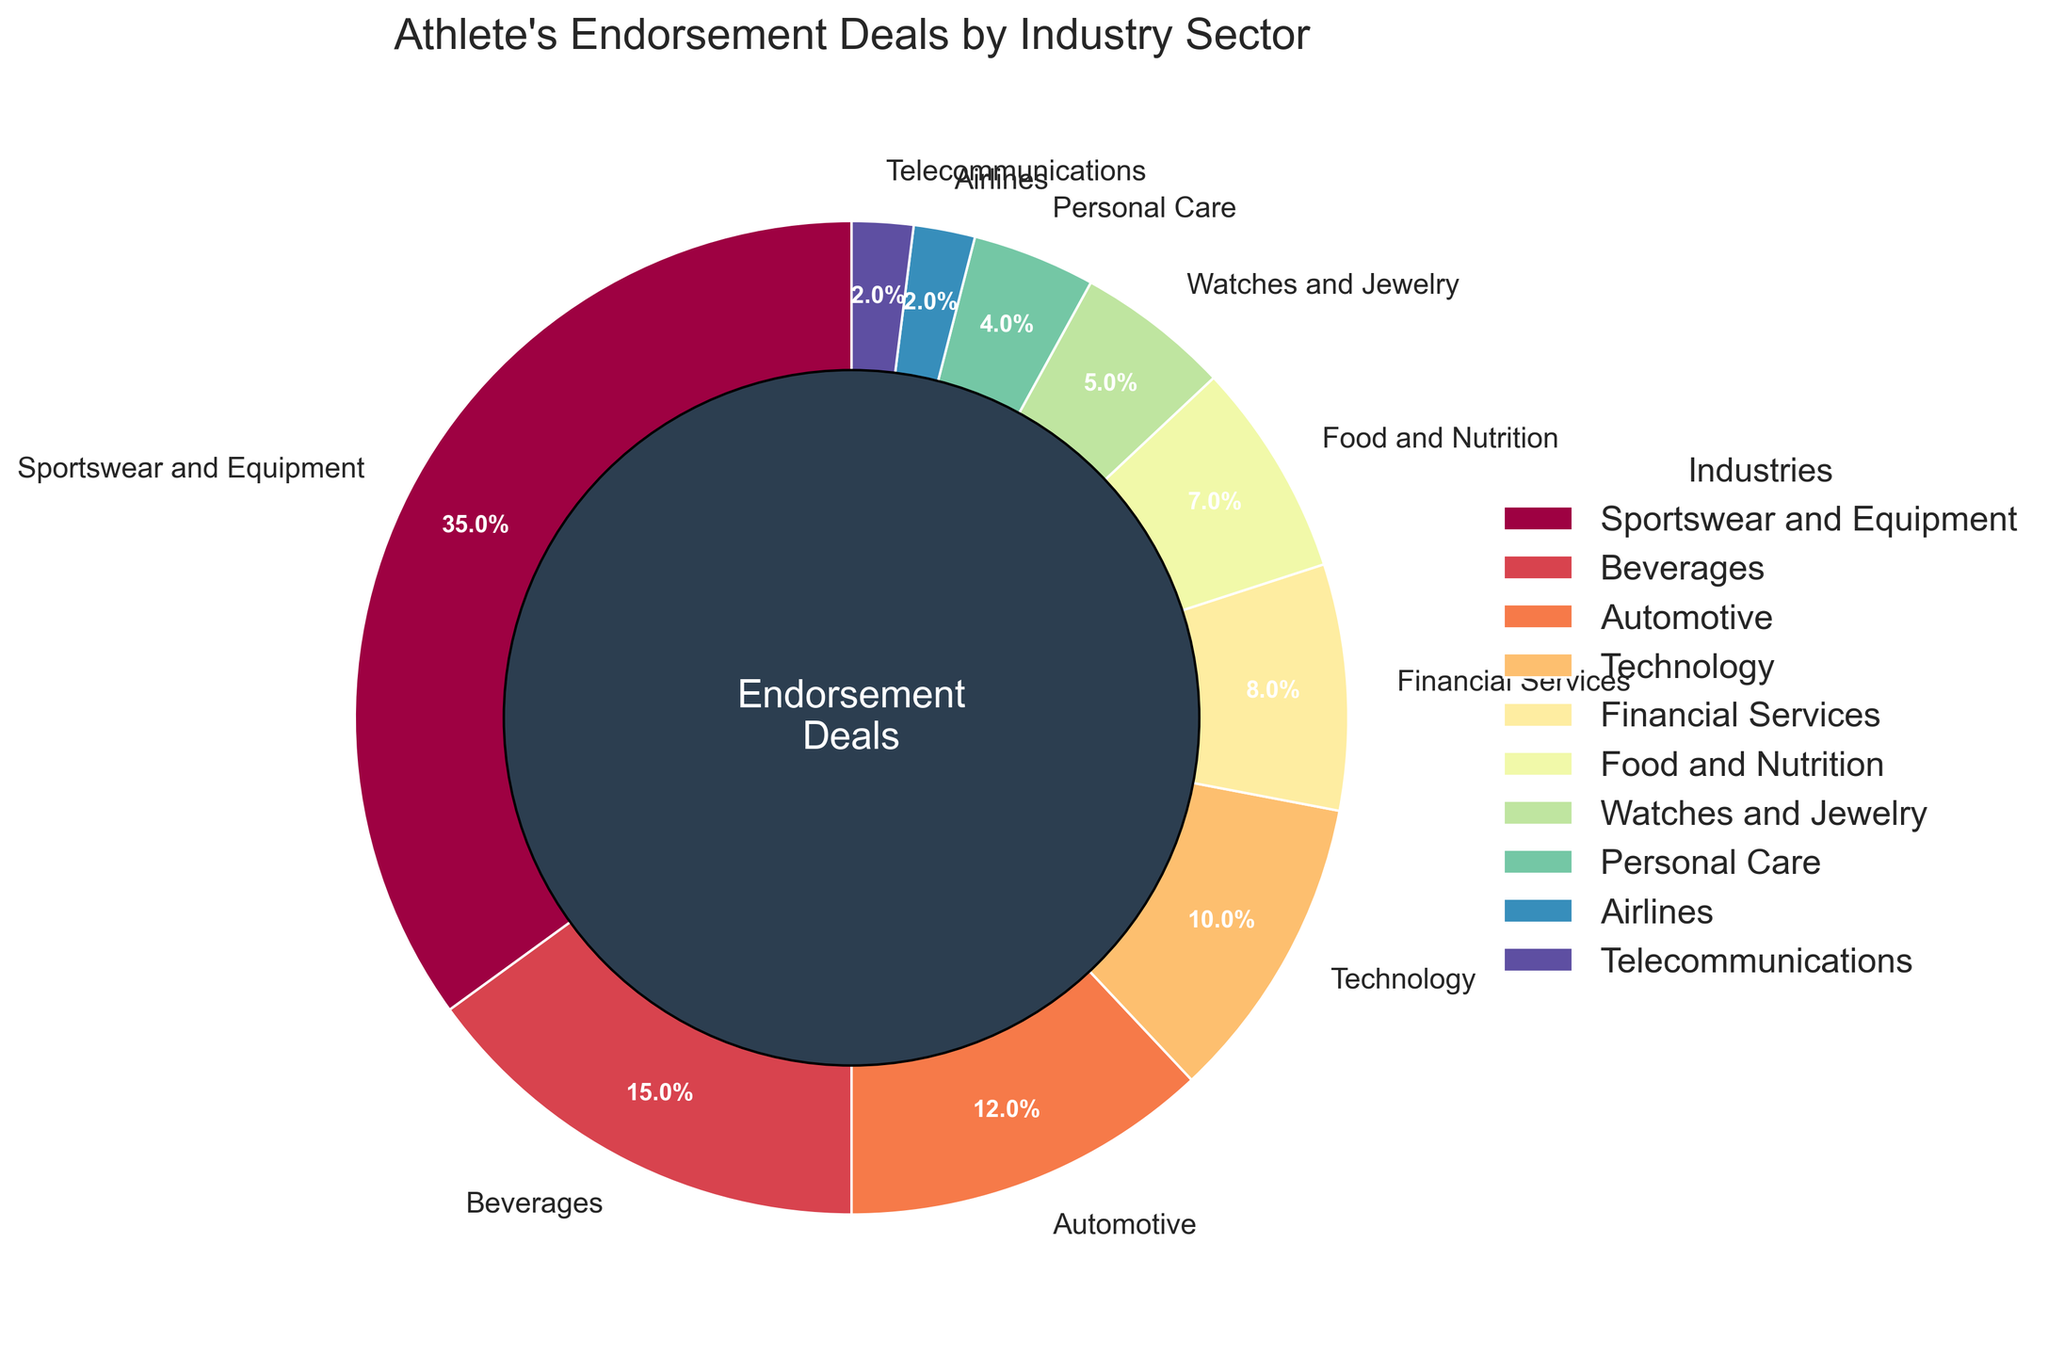Which industry has the largest allocation in the athlete's endorsement deals? The pie chart indicates that "Sportswear and Equipment" has the largest allocation with a percentage of 35%
Answer: Sportswear and Equipment Which two industry sectors have the smallest allocation in the endorsement deals? Looking at the percentages in the pie chart, "Airlines" and "Telecommunications" each have 2%, making them the smallest sectors in terms of endorsement allocation
Answer: Airlines and Telecommunications What is the combined percentage of endorsements in the Technology and Financial Services sectors? Adding the percentages for "Technology" (10%) and "Financial Services" (8%) gives a combined total of 10% + 8% = 18%
Answer: 18% How does the percentage of endorsements for Personal Care compare with that for Food and Nutrition? The pie chart shows Personal Care has 4% while Food and Nutrition has 7%, meaning Food and Nutrition has a higher percentage by 3%
Answer: Food and Nutrition has 3% more What are the combined endorsement percentages for the top three industry sectors? The top three sectors are Sportswear and Equipment (35%), Beverages (15%), and Automotive (12%). Their combined percentage is 35% + 15% + 12% = 62%
Answer: 62% What industry is assigned the color closest to purple in the pie chart? Observing the color scheme, and knowing that purple often appears at the lower end of the spectrum, "Automotive" is the industry with the color closest to purple
Answer: Automotive Which has a higher allocation, Watches and Jewelry or Financial Services, and by how much? Financial Services has 8% and Watches and Jewelry has 5%. The difference is 8% - 5% = 3%
Answer: Financial Services by 3% By how much does the percentage of endorsements in the Food and Nutrition sector differ from the Technology sector? The pie chart shows Technology at 10% and Food and Nutrition at 7%. The difference is 10% - 7% = 3%
Answer: 3% What is the percentage gap between the endorsements in the Beverage sector compared to the Personal Care sector? Beverages has 15% and Personal Care has 4%. The gap is 15% - 4% = 11%
Answer: 11% What sectors contribute to less than 10% of the total endorsement deals each? The segments with less than 10% are: Financial Services (8%), Food and Nutrition (7%), Watches and Jewelry (5%), Personal Care (4%), Airlines (2%), and Telecommunications (2%)
Answer: Financial Services, Food and Nutrition, Watches and Jewelry, Personal Care, Airlines, Telecommunications 